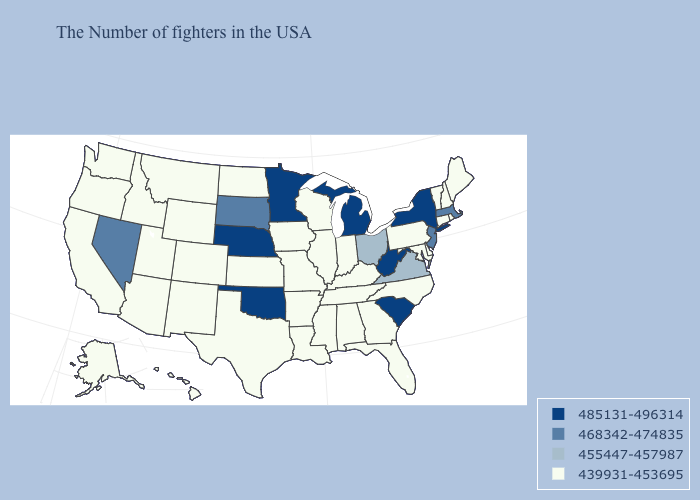What is the lowest value in the USA?
Concise answer only. 439931-453695. What is the value of Montana?
Short answer required. 439931-453695. Does Tennessee have the lowest value in the South?
Keep it brief. Yes. What is the value of West Virginia?
Short answer required. 485131-496314. Which states have the lowest value in the USA?
Quick response, please. Maine, Rhode Island, New Hampshire, Vermont, Connecticut, Delaware, Maryland, Pennsylvania, North Carolina, Florida, Georgia, Kentucky, Indiana, Alabama, Tennessee, Wisconsin, Illinois, Mississippi, Louisiana, Missouri, Arkansas, Iowa, Kansas, Texas, North Dakota, Wyoming, Colorado, New Mexico, Utah, Montana, Arizona, Idaho, California, Washington, Oregon, Alaska, Hawaii. How many symbols are there in the legend?
Be succinct. 4. What is the value of Colorado?
Be succinct. 439931-453695. What is the highest value in the MidWest ?
Keep it brief. 485131-496314. Does West Virginia have a higher value than Oklahoma?
Keep it brief. No. Does Connecticut have a lower value than West Virginia?
Concise answer only. Yes. What is the value of Nevada?
Give a very brief answer. 468342-474835. Among the states that border Iowa , does South Dakota have the lowest value?
Write a very short answer. No. What is the value of Alaska?
Short answer required. 439931-453695. Does Ohio have the lowest value in the MidWest?
Answer briefly. No. Among the states that border Delaware , which have the lowest value?
Answer briefly. Maryland, Pennsylvania. 